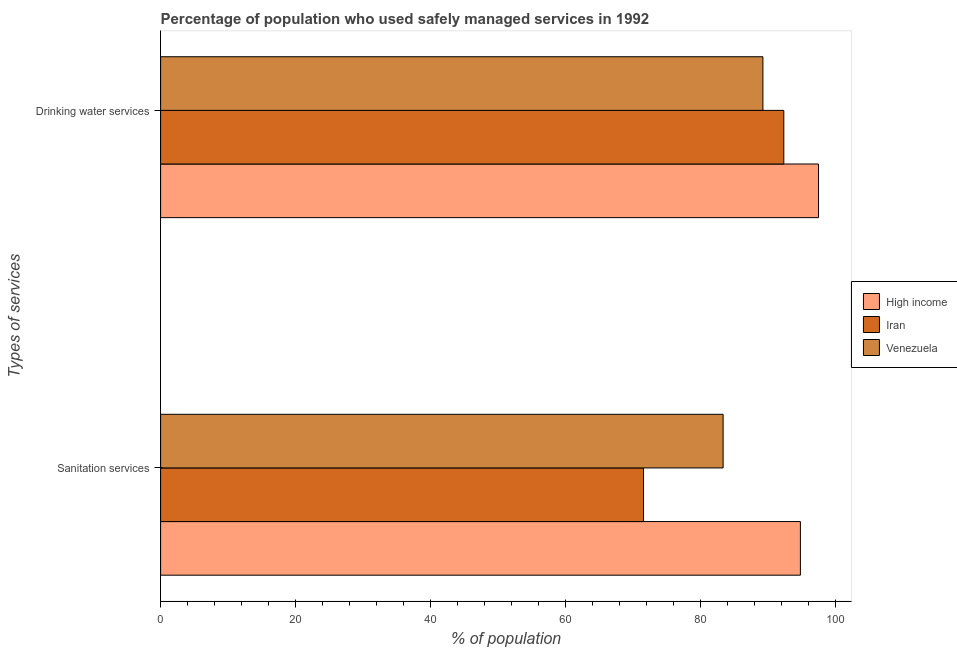How many different coloured bars are there?
Your response must be concise. 3. How many groups of bars are there?
Offer a terse response. 2. Are the number of bars on each tick of the Y-axis equal?
Keep it short and to the point. Yes. How many bars are there on the 1st tick from the top?
Ensure brevity in your answer.  3. How many bars are there on the 1st tick from the bottom?
Keep it short and to the point. 3. What is the label of the 2nd group of bars from the top?
Keep it short and to the point. Sanitation services. What is the percentage of population who used sanitation services in Venezuela?
Your answer should be compact. 83.4. Across all countries, what is the maximum percentage of population who used sanitation services?
Give a very brief answer. 94.86. Across all countries, what is the minimum percentage of population who used drinking water services?
Ensure brevity in your answer.  89.3. In which country was the percentage of population who used sanitation services maximum?
Make the answer very short. High income. In which country was the percentage of population who used sanitation services minimum?
Your answer should be compact. Iran. What is the total percentage of population who used drinking water services in the graph?
Your answer should be very brief. 279.25. What is the difference between the percentage of population who used drinking water services in Venezuela and that in High income?
Your response must be concise. -8.25. What is the difference between the percentage of population who used drinking water services in Iran and the percentage of population who used sanitation services in High income?
Provide a succinct answer. -2.46. What is the average percentage of population who used sanitation services per country?
Ensure brevity in your answer.  83.29. What is the difference between the percentage of population who used drinking water services and percentage of population who used sanitation services in Venezuela?
Your response must be concise. 5.9. What is the ratio of the percentage of population who used drinking water services in High income to that in Venezuela?
Provide a succinct answer. 1.09. What does the 2nd bar from the top in Sanitation services represents?
Your answer should be very brief. Iran. What does the 2nd bar from the bottom in Sanitation services represents?
Keep it short and to the point. Iran. How many bars are there?
Offer a very short reply. 6. What is the difference between two consecutive major ticks on the X-axis?
Make the answer very short. 20. Does the graph contain any zero values?
Offer a very short reply. No. Where does the legend appear in the graph?
Offer a terse response. Center right. How are the legend labels stacked?
Offer a very short reply. Vertical. What is the title of the graph?
Give a very brief answer. Percentage of population who used safely managed services in 1992. What is the label or title of the X-axis?
Your response must be concise. % of population. What is the label or title of the Y-axis?
Your response must be concise. Types of services. What is the % of population of High income in Sanitation services?
Ensure brevity in your answer.  94.86. What is the % of population of Iran in Sanitation services?
Keep it short and to the point. 71.6. What is the % of population of Venezuela in Sanitation services?
Give a very brief answer. 83.4. What is the % of population of High income in Drinking water services?
Your answer should be very brief. 97.55. What is the % of population of Iran in Drinking water services?
Give a very brief answer. 92.4. What is the % of population in Venezuela in Drinking water services?
Ensure brevity in your answer.  89.3. Across all Types of services, what is the maximum % of population of High income?
Provide a short and direct response. 97.55. Across all Types of services, what is the maximum % of population in Iran?
Give a very brief answer. 92.4. Across all Types of services, what is the maximum % of population in Venezuela?
Provide a short and direct response. 89.3. Across all Types of services, what is the minimum % of population of High income?
Your answer should be very brief. 94.86. Across all Types of services, what is the minimum % of population of Iran?
Your answer should be very brief. 71.6. Across all Types of services, what is the minimum % of population in Venezuela?
Your response must be concise. 83.4. What is the total % of population in High income in the graph?
Ensure brevity in your answer.  192.41. What is the total % of population of Iran in the graph?
Provide a succinct answer. 164. What is the total % of population of Venezuela in the graph?
Ensure brevity in your answer.  172.7. What is the difference between the % of population of High income in Sanitation services and that in Drinking water services?
Offer a terse response. -2.69. What is the difference between the % of population in Iran in Sanitation services and that in Drinking water services?
Provide a short and direct response. -20.8. What is the difference between the % of population of Venezuela in Sanitation services and that in Drinking water services?
Your answer should be compact. -5.9. What is the difference between the % of population of High income in Sanitation services and the % of population of Iran in Drinking water services?
Your answer should be compact. 2.46. What is the difference between the % of population in High income in Sanitation services and the % of population in Venezuela in Drinking water services?
Your response must be concise. 5.56. What is the difference between the % of population in Iran in Sanitation services and the % of population in Venezuela in Drinking water services?
Make the answer very short. -17.7. What is the average % of population in High income per Types of services?
Make the answer very short. 96.2. What is the average % of population in Iran per Types of services?
Your response must be concise. 82. What is the average % of population in Venezuela per Types of services?
Offer a very short reply. 86.35. What is the difference between the % of population in High income and % of population in Iran in Sanitation services?
Give a very brief answer. 23.26. What is the difference between the % of population of High income and % of population of Venezuela in Sanitation services?
Your response must be concise. 11.46. What is the difference between the % of population of Iran and % of population of Venezuela in Sanitation services?
Keep it short and to the point. -11.8. What is the difference between the % of population in High income and % of population in Iran in Drinking water services?
Your response must be concise. 5.15. What is the difference between the % of population in High income and % of population in Venezuela in Drinking water services?
Offer a very short reply. 8.25. What is the ratio of the % of population of High income in Sanitation services to that in Drinking water services?
Give a very brief answer. 0.97. What is the ratio of the % of population in Iran in Sanitation services to that in Drinking water services?
Make the answer very short. 0.77. What is the ratio of the % of population in Venezuela in Sanitation services to that in Drinking water services?
Your answer should be compact. 0.93. What is the difference between the highest and the second highest % of population of High income?
Your answer should be very brief. 2.69. What is the difference between the highest and the second highest % of population of Iran?
Provide a succinct answer. 20.8. What is the difference between the highest and the lowest % of population in High income?
Your response must be concise. 2.69. What is the difference between the highest and the lowest % of population of Iran?
Provide a succinct answer. 20.8. What is the difference between the highest and the lowest % of population in Venezuela?
Keep it short and to the point. 5.9. 